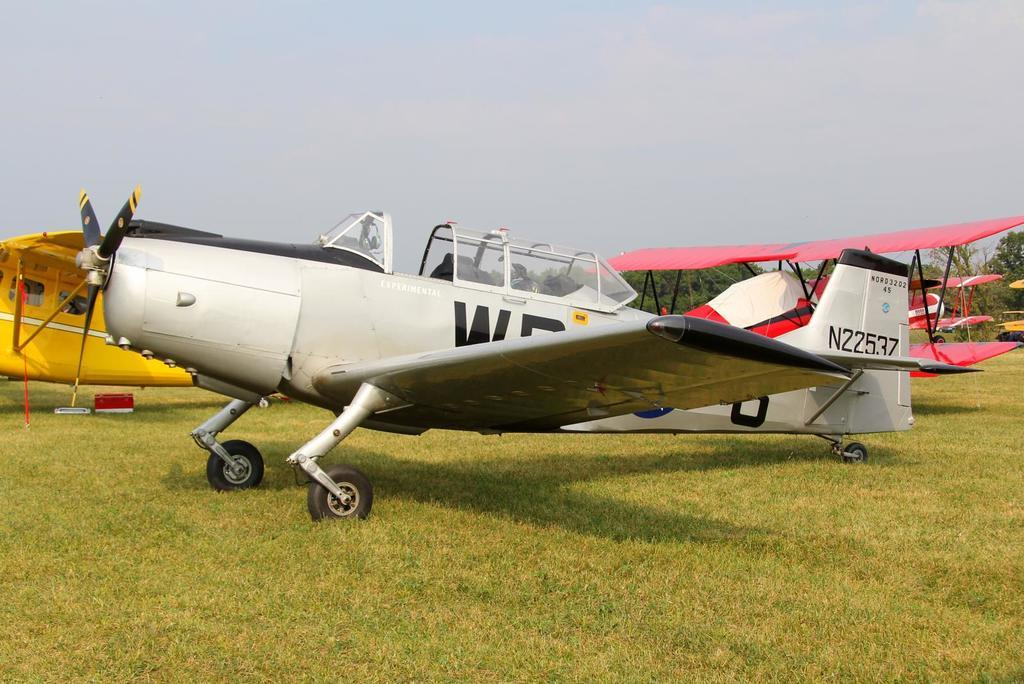<image>
Relay a brief, clear account of the picture shown. Airplane number N22537 is parked on the grass. 